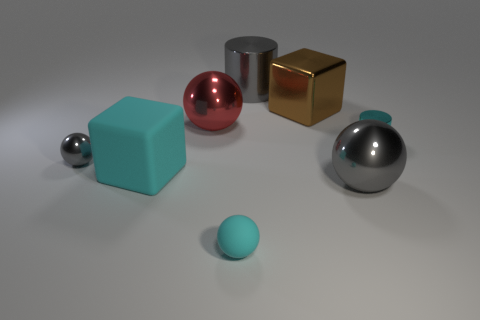Can you describe the texture on the surfaces in the scene? Certainly! The metal objects have a sleek and shiny surface, reflecting the environment with a high gloss finish. The metallic sphere appears exceptionally reflective, almost mirror-like. The cube seems to have a slightly matte finish, suggesting a less polished texture compared to the other metal objects. The ground has a diffuse, rough texture, which scatters the light and gives it a flat appearance. 